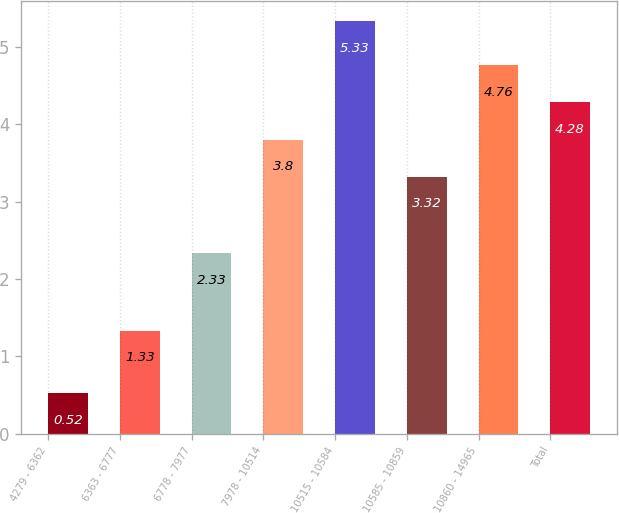<chart> <loc_0><loc_0><loc_500><loc_500><bar_chart><fcel>4279 - 6362<fcel>6363 - 6777<fcel>6778 - 7977<fcel>7978 - 10514<fcel>10515 - 10584<fcel>10585 - 10859<fcel>10860 - 14965<fcel>Total<nl><fcel>0.52<fcel>1.33<fcel>2.33<fcel>3.8<fcel>5.33<fcel>3.32<fcel>4.76<fcel>4.28<nl></chart> 